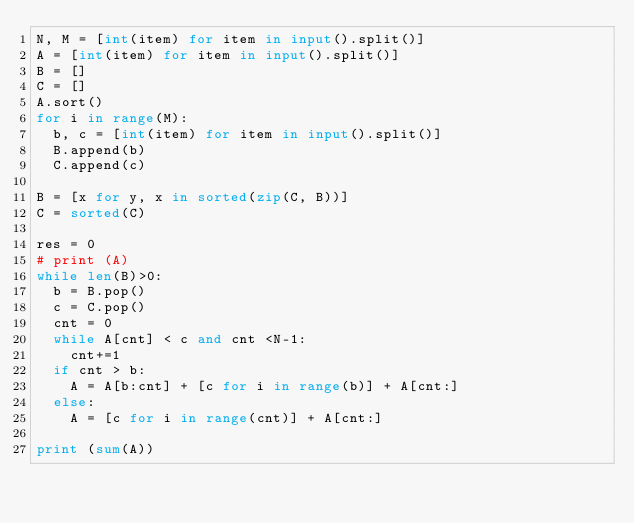Convert code to text. <code><loc_0><loc_0><loc_500><loc_500><_Python_>N, M = [int(item) for item in input().split()]
A = [int(item) for item in input().split()]
B = []
C = []
A.sort()
for i in range(M):
  b, c = [int(item) for item in input().split()]
  B.append(b)
  C.append(c)

B = [x for y, x in sorted(zip(C, B))]
C = sorted(C)

res = 0
# print (A)
while len(B)>0:
  b = B.pop()
  c = C.pop()
  cnt = 0
  while A[cnt] < c and cnt <N-1:
    cnt+=1
  if cnt > b:
    A = A[b:cnt] + [c for i in range(b)] + A[cnt:]
  else:
    A = [c for i in range(cnt)] + A[cnt:]
  
print (sum(A))</code> 